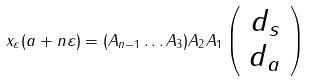<formula> <loc_0><loc_0><loc_500><loc_500>x _ { \varepsilon } ( a + n \varepsilon ) = ( A _ { n - 1 } \dots A _ { 3 } ) A _ { 2 } A _ { 1 } \left ( \begin{array} { c } d _ { s } \\ d _ { a } \end{array} \right )</formula> 